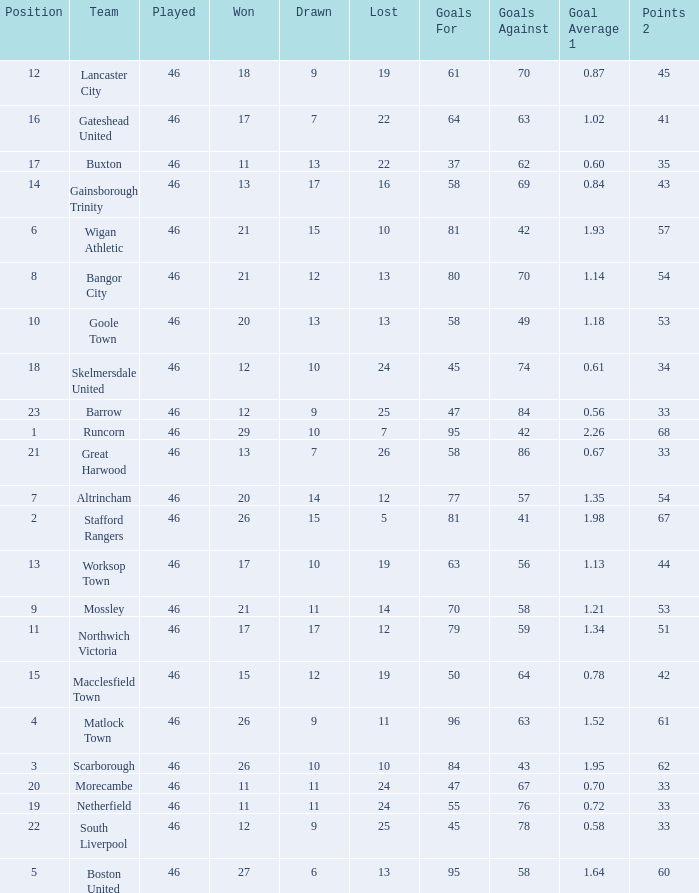Which team had goal averages of 1.34? Northwich Victoria. 